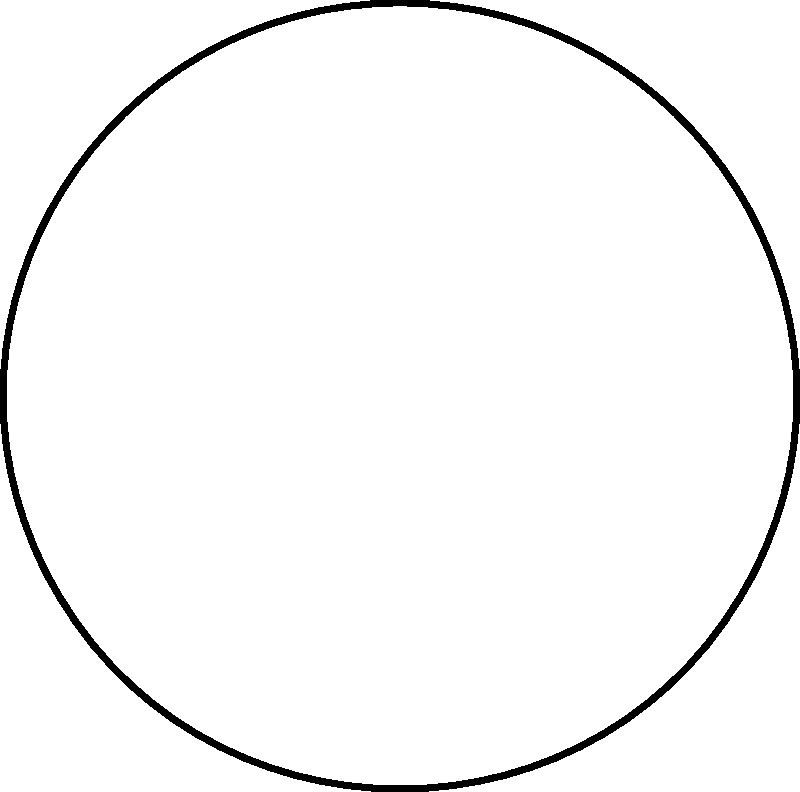In the diagram, the blue curve represents a normal hippocampus, while the red curve shows an atrophied hippocampus in a trauma-exposed individual. If the angle $\theta$ measures the degree of hippocampal atrophy, and we know that the normal hippocampal curvature is approximately 60°, what is the approximate angle $\theta$ of atrophy shown in the diagram? To determine the angle of hippocampal atrophy:

1. Observe that the normal hippocampus (blue curve) has a higher curvature than the atrophied hippocampus (red curve).

2. The angle $\theta$ represents the difference between these curvatures.

3. Given: The normal hippocampal curvature is approximately 60°.

4. Estimate the curvature of the atrophied hippocampus based on the diagram. It appears to be about 45°.

5. Calculate the difference:
   $\theta = \text{Normal curvature} - \text{Atrophied curvature}$
   $\theta \approx 60° - 45° = 15°$

6. This 15° difference represents the approximate angle of hippocampal atrophy shown in the diagram.
Answer: $15°$ 